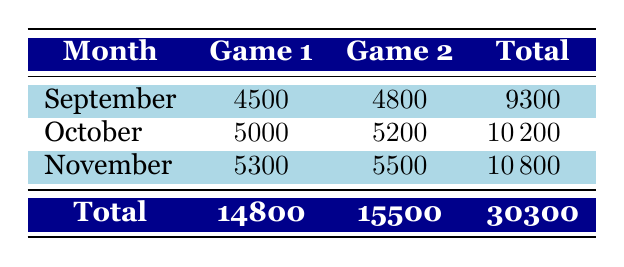What was the attendance for the game against the Mountainview Eagles in September? The table shows that in September, the game against the Mountainview Eagles had an attendance of 4500.
Answer: 4500 What is the total attendance for all the games in October? In October, the attendance for the two games is 5000 and 5200. Adding these gives a total attendance of 5000 + 5200 = 10200.
Answer: 10200 Did the attendance for the November games exceed 10000? The total attendance for the two November games is 5300 + 5500 = 10800, which does exceed 10000.
Answer: Yes What is the average attendance for the games in September? The total attendance for September is 9300 (which includes the two games of 4500 and 4800). The average is calculated as 9300 divided by 2 (the number of games), which equals 4650.
Answer: 4650 Which month had the highest total attendance? The total attendance for each month is: September 9300, October 10200, November 10800. The month with the highest total attendance is November with 10800.
Answer: November What is the difference in attendance between the first game in November and the second game in September? The attendance for the first game in November is 5300, while for the second game in September it is 4800. The difference is calculated as 5300 - 4800 = 500.
Answer: 500 How many total attendees were there across all games played? To find the total attendance across all games, sum the attendance for all games: 4500 + 4800 + 5000 + 5200 + 5300 + 5500 = 30300.
Answer: 30300 Was the attendance for the game against the Cedar Hill Chargers more than the average attendance for the games in September? The attendance for the game against the Cedar Hill Chargers is 5200, and the average attendance for September is calculated as 4650. Since 5200 > 4650, the answer is yes.
Answer: Yes What is the total attendance for all September games combined, and how does it compare to the total for October? The total attendance for September is 9300 and for October is 10200. Since 9300 is less than 10200, we see that attendance in September is lower than in October.
Answer: September is lower 